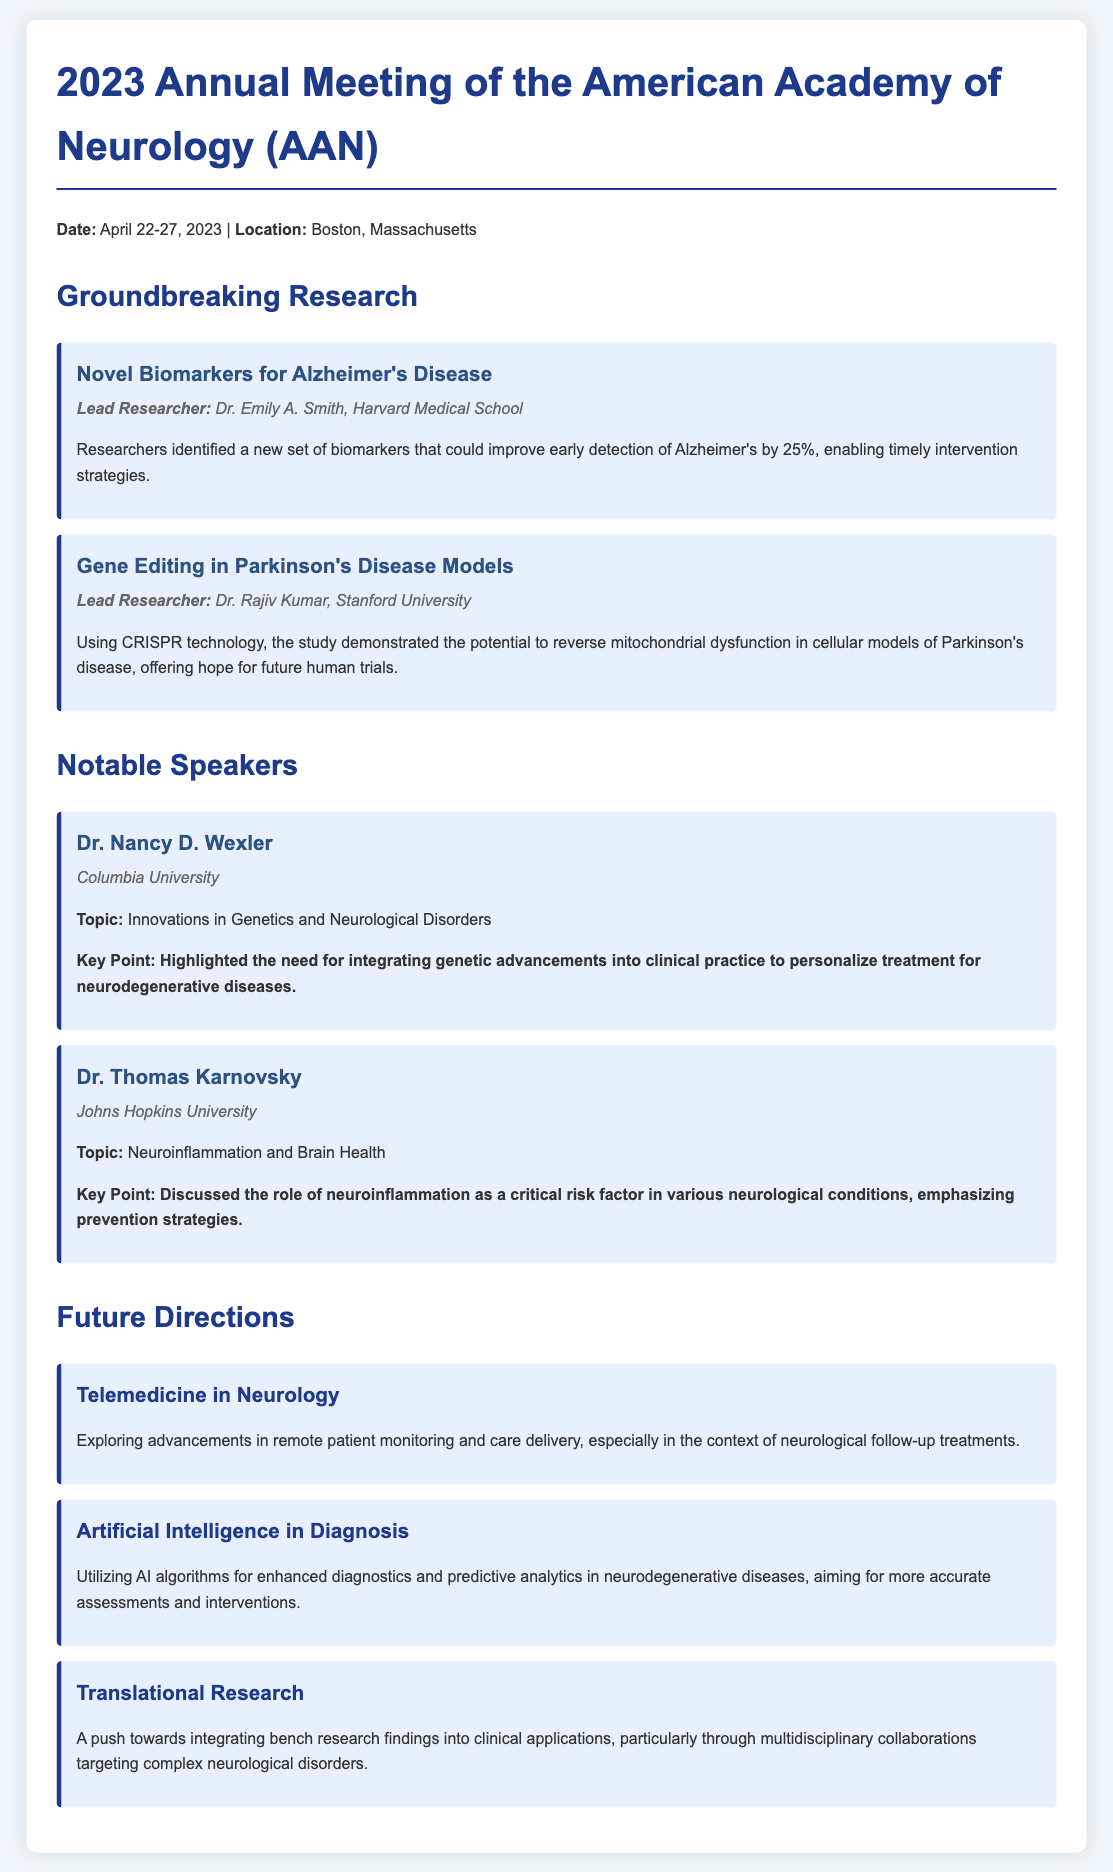What are the dates of the conference? The dates for the conference are explicitly stated in the document as April 22-27, 2023.
Answer: April 22-27, 2023 Who is the lead researcher for the study on novel biomarkers for Alzheimer's Disease? The document clearly identifies Dr. Emily A. Smith as the lead researcher for this study.
Answer: Dr. Emily A. Smith What topic did Dr. Nancy D. Wexler discuss? The document specifies that Dr. Nancy D. Wexler spoke on the topic of "Innovations in Genetics and Neurological Disorders."
Answer: Innovations in Genetics and Neurological Disorders What technology was used in the study on gene editing in Parkinson's Disease models? The document states that CRISPR technology was used in the study on gene editing.
Answer: CRISPR What is one future direction mentioned regarding artificial intelligence? The document indicates that a future direction is utilizing AI algorithms for enhanced diagnostics and predictive analytics in neurodegenerative diseases.
Answer: Enhanced diagnostics and predictive analytics What is the key point made by Dr. Thomas Karnovsky? The document highlights that Dr. Thomas Karnovsky discussed neuroinflammation and its critical role in various neurological conditions.
Answer: Neuroinflammation as a critical risk factor 